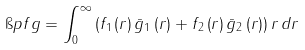<formula> <loc_0><loc_0><loc_500><loc_500>\i p { f } { g } = \int _ { 0 } ^ { \infty } \left ( f _ { 1 } \left ( r \right ) \bar { g } _ { 1 } \left ( r \right ) + f _ { 2 } \left ( r \right ) \bar { g } _ { 2 } \left ( r \right ) \right ) r \, d r</formula> 